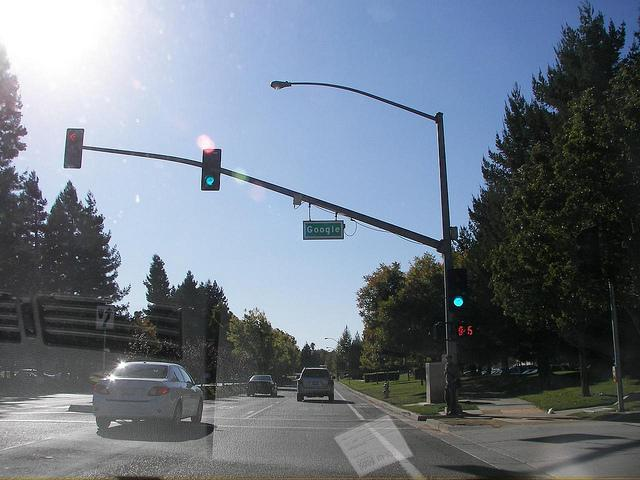What street is marked by the traffic light? google 